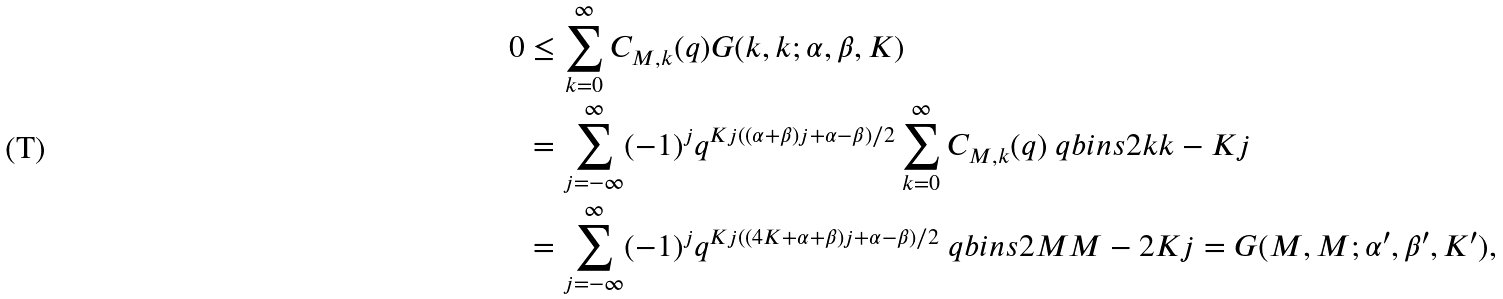<formula> <loc_0><loc_0><loc_500><loc_500>0 & \leq \sum _ { k = 0 } ^ { \infty } C _ { M , k } ( q ) G ( k , k ; \alpha , \beta , K ) \\ & = \sum _ { j = - \infty } ^ { \infty } ( - 1 ) ^ { j } q ^ { K j ( ( \alpha + \beta ) j + \alpha - \beta ) / 2 } \sum _ { k = 0 } ^ { \infty } C _ { M , k } ( q ) \ q b i n s { 2 k } { k - K j } \\ & = \sum _ { j = - \infty } ^ { \infty } ( - 1 ) ^ { j } q ^ { K j ( ( 4 K + \alpha + \beta ) j + \alpha - \beta ) / 2 } \ q b i n s { 2 M } { M - 2 K j } = G ( M , M ; \alpha ^ { \prime } , \beta ^ { \prime } , K ^ { \prime } ) ,</formula> 